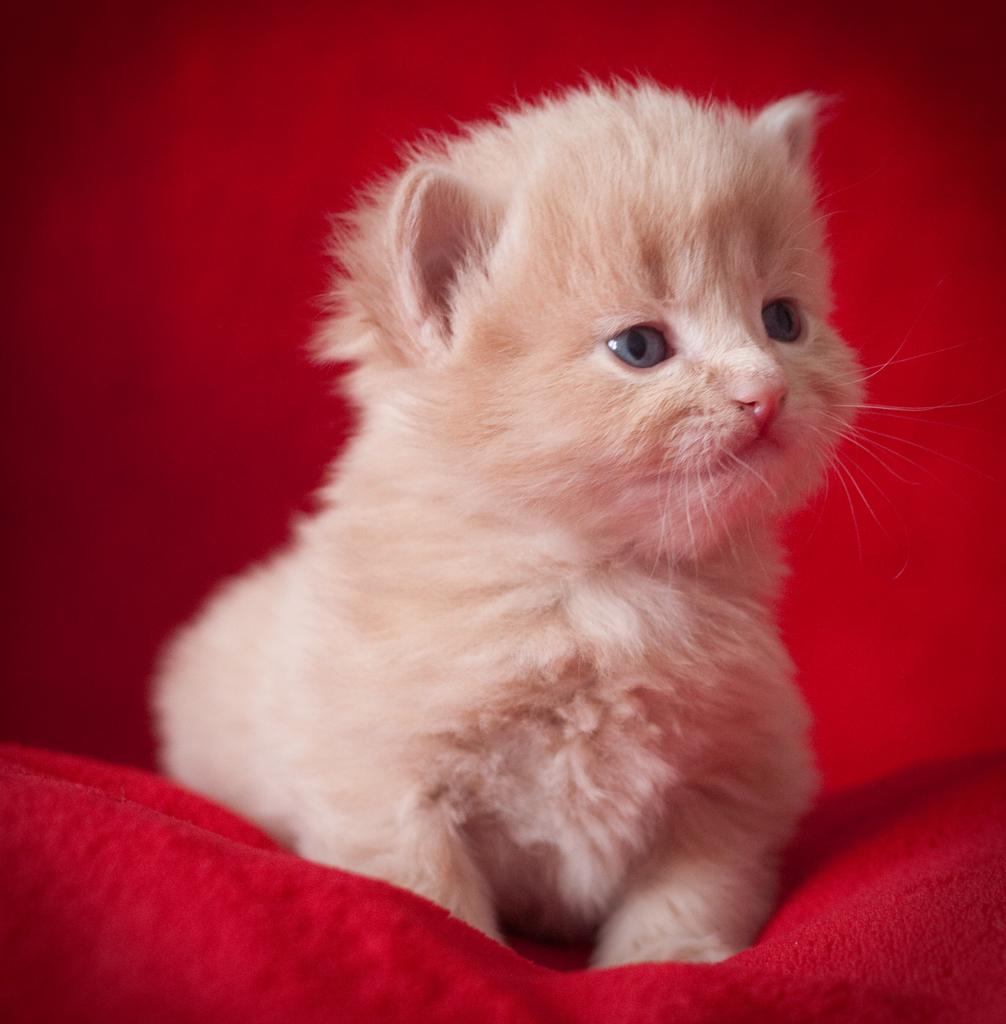What type of animal is in the image? There is a white cat in the image. What is the cat sitting or standing on? The cat is on a red object. Can you describe the background of the image? The background of the image is blurry. What type of approval does the cat receive from the authority in the image? There is no indication of approval or authority in the image; it simply features a white cat on a red object with a blurry background. 